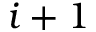<formula> <loc_0><loc_0><loc_500><loc_500>i + 1</formula> 